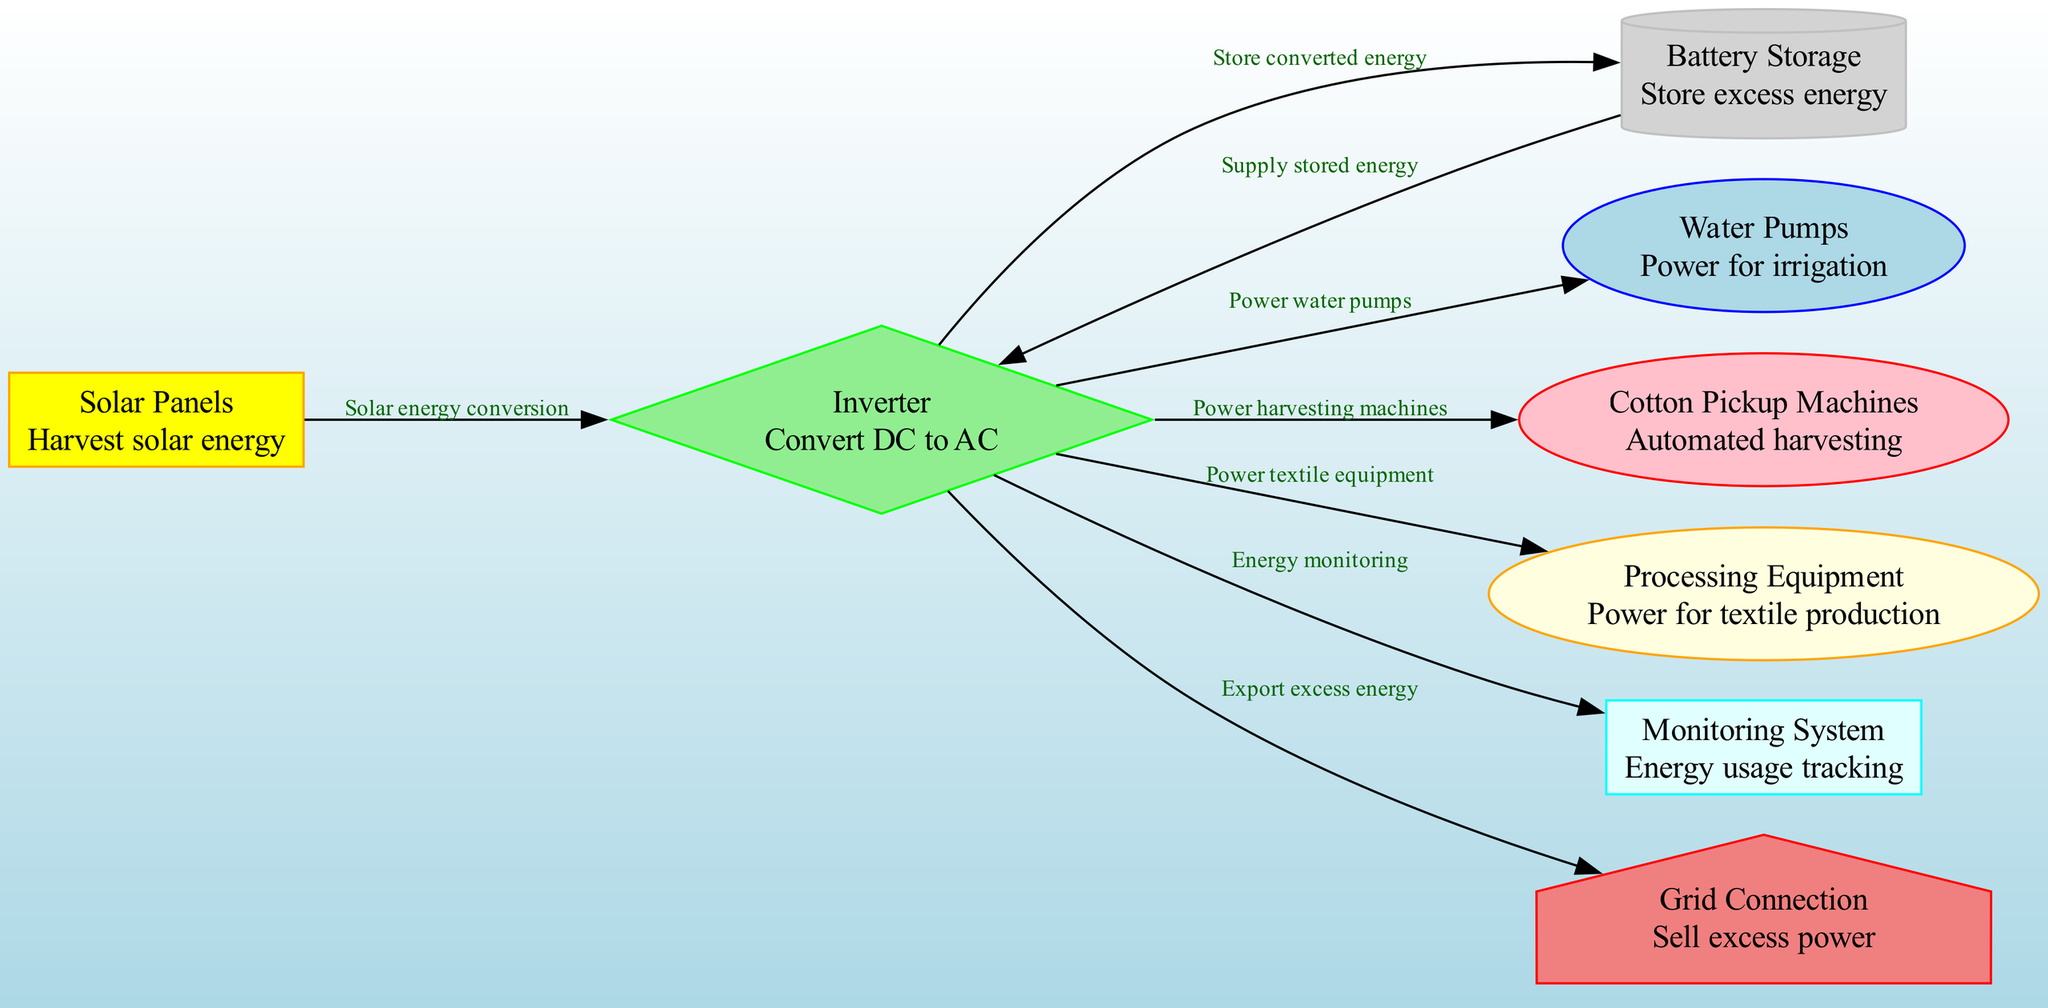What is the first component in the diagram? The first component listed in the nodes is "Solar Panels." It is the starting point for the flow as it is responsible for harvesting solar energy, which is indicated as the first node in the diagram.
Answer: Solar Panels How many nodes are present in the diagram? The total number of nodes in the diagram is counted by looking at the list provided. There are 8 unique nodes in the data representing different components in the solar energy process.
Answer: 8 What does the Inverter do? The Inverter is responsible for converting direct current (DC) energy to alternating current (AC) energy. This is depicted in the description provided in the nodes section.
Answer: Convert DC to AC Which components receive power from the Inverter? The components that receive power from the Inverter are the Water Pumps, Cotton Pickup Machines, and Processing Equipment. This can be determined by following the outgoing edges from the Inverter node in the diagram.
Answer: Water Pumps, Cotton Pickup Machines, Processing Equipment What is the purpose of Battery Storage in the process? Battery Storage is utilized for storing excess solar energy that has been converted and is not immediately needed. This is indicated in the description for Battery Storage in the nodes section.
Answer: Store excess energy How does excess energy get exported from the system? Excess energy is exported from the system through the Grid Connection. The relationship is shown in the edges originating from the Inverter leading to Grid Connection, marked as "Export excess energy."
Answer: Grid Connection What role does the Monitoring System play? The Monitoring System's role is to track energy usage, which is reflected in the description in the nodes section, indicating its function in the overall solar energy utilization.
Answer: Energy usage tracking Which node acts as the starting point for solar energy harvesting in cotton farming? The starting point for solar energy harvesting in the diagram is the Solar Panels node. This is confirmed by its position as the first node associated with the harvesting of solar energy.
Answer: Solar Panels What is the function of the edges drawn in the diagram? The edges in the diagram represent the relationships and flow of energy between different components. Each edge describes how energy transfers from one node to another, indicating the direction and process of energy utilization.
Answer: Energy transfer relationships 